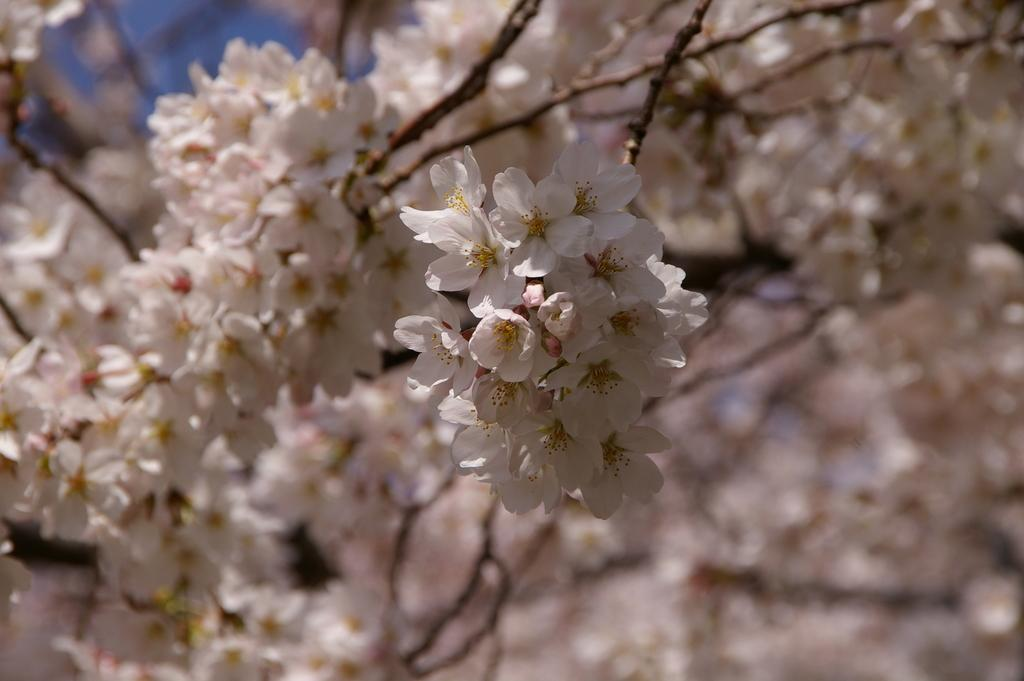What is located on the left side of the image? There are branches of a tree on the left side of the image. What can be seen on the branches? The branches have white color flowers. How would you describe the background of the image? The background of the image is blurred. What type of cheese is visible on the branches of the tree in the image? There is no cheese present on the branches of the tree in the image. The branches have white color flowers, not cheese. 